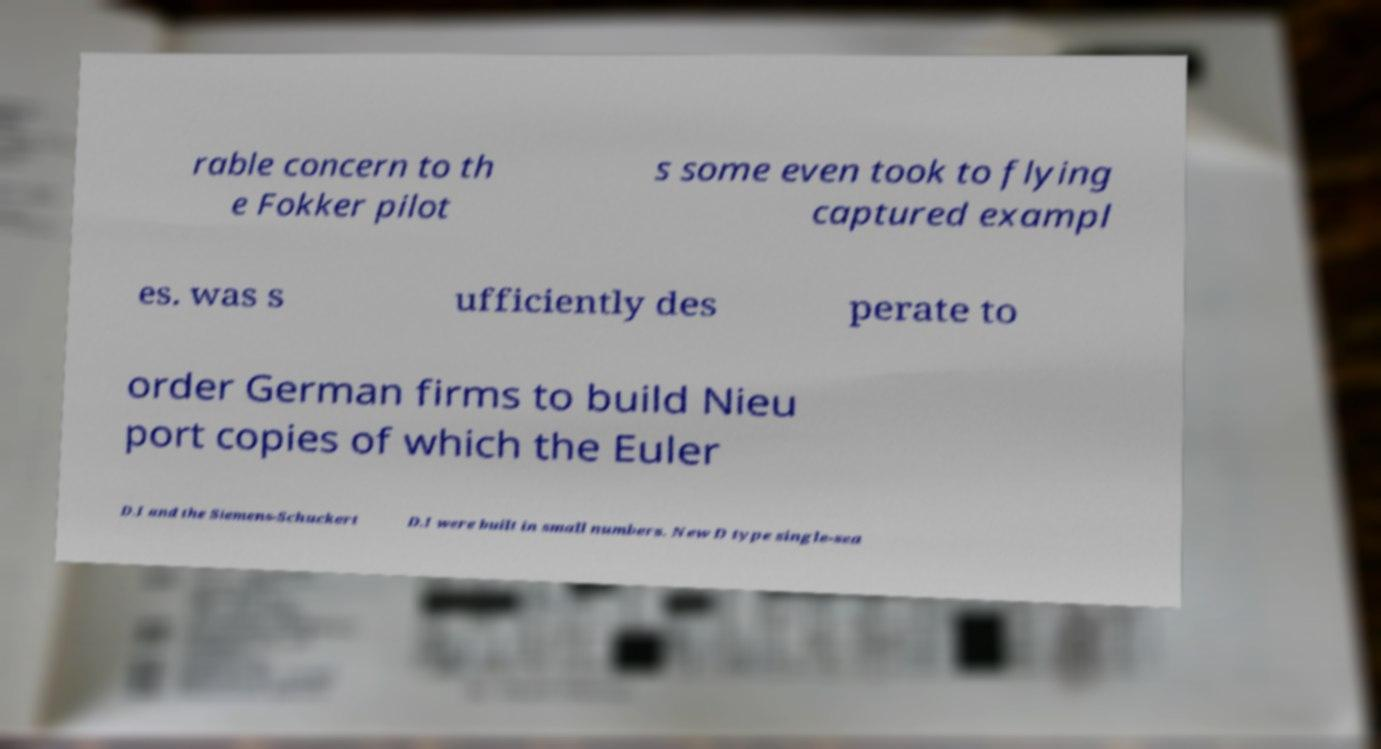I need the written content from this picture converted into text. Can you do that? rable concern to th e Fokker pilot s some even took to flying captured exampl es. was s ufficiently des perate to order German firms to build Nieu port copies of which the Euler D.I and the Siemens-Schuckert D.I were built in small numbers. New D type single-sea 